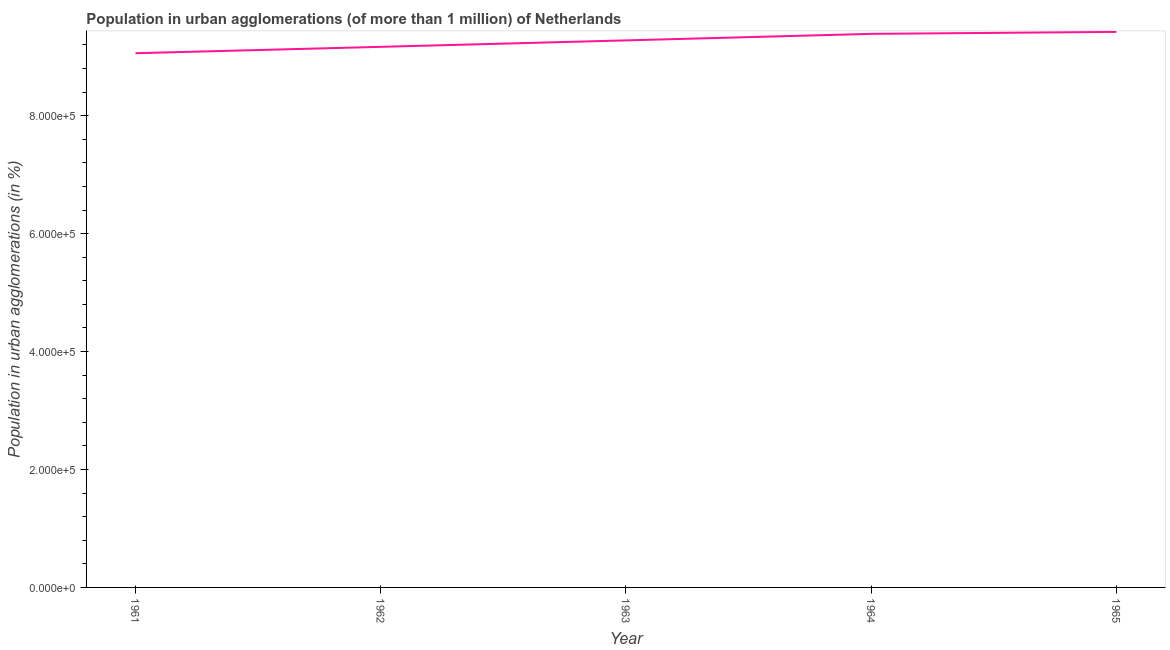What is the population in urban agglomerations in 1965?
Your answer should be very brief. 9.42e+05. Across all years, what is the maximum population in urban agglomerations?
Offer a terse response. 9.42e+05. Across all years, what is the minimum population in urban agglomerations?
Keep it short and to the point. 9.06e+05. In which year was the population in urban agglomerations maximum?
Make the answer very short. 1965. In which year was the population in urban agglomerations minimum?
Give a very brief answer. 1961. What is the sum of the population in urban agglomerations?
Your answer should be compact. 4.63e+06. What is the difference between the population in urban agglomerations in 1961 and 1962?
Make the answer very short. -1.08e+04. What is the average population in urban agglomerations per year?
Provide a succinct answer. 9.26e+05. What is the median population in urban agglomerations?
Keep it short and to the point. 9.28e+05. In how many years, is the population in urban agglomerations greater than 80000 %?
Ensure brevity in your answer.  5. Do a majority of the years between 1964 and 1962 (inclusive) have population in urban agglomerations greater than 640000 %?
Keep it short and to the point. No. What is the ratio of the population in urban agglomerations in 1962 to that in 1965?
Your answer should be very brief. 0.97. Is the population in urban agglomerations in 1961 less than that in 1964?
Ensure brevity in your answer.  Yes. Is the difference between the population in urban agglomerations in 1962 and 1964 greater than the difference between any two years?
Keep it short and to the point. No. What is the difference between the highest and the second highest population in urban agglomerations?
Make the answer very short. 3331. Is the sum of the population in urban agglomerations in 1961 and 1962 greater than the maximum population in urban agglomerations across all years?
Offer a terse response. Yes. What is the difference between the highest and the lowest population in urban agglomerations?
Provide a succinct answer. 3.62e+04. How many lines are there?
Make the answer very short. 1. How many years are there in the graph?
Ensure brevity in your answer.  5. What is the difference between two consecutive major ticks on the Y-axis?
Give a very brief answer. 2.00e+05. Are the values on the major ticks of Y-axis written in scientific E-notation?
Offer a terse response. Yes. Does the graph contain any zero values?
Provide a short and direct response. No. Does the graph contain grids?
Offer a very short reply. No. What is the title of the graph?
Offer a very short reply. Population in urban agglomerations (of more than 1 million) of Netherlands. What is the label or title of the Y-axis?
Give a very brief answer. Population in urban agglomerations (in %). What is the Population in urban agglomerations (in %) in 1961?
Provide a succinct answer. 9.06e+05. What is the Population in urban agglomerations (in %) in 1962?
Your answer should be very brief. 9.17e+05. What is the Population in urban agglomerations (in %) of 1963?
Offer a terse response. 9.28e+05. What is the Population in urban agglomerations (in %) of 1964?
Keep it short and to the point. 9.39e+05. What is the Population in urban agglomerations (in %) of 1965?
Your answer should be compact. 9.42e+05. What is the difference between the Population in urban agglomerations (in %) in 1961 and 1962?
Your response must be concise. -1.08e+04. What is the difference between the Population in urban agglomerations (in %) in 1961 and 1963?
Keep it short and to the point. -2.18e+04. What is the difference between the Population in urban agglomerations (in %) in 1961 and 1964?
Make the answer very short. -3.28e+04. What is the difference between the Population in urban agglomerations (in %) in 1961 and 1965?
Your response must be concise. -3.62e+04. What is the difference between the Population in urban agglomerations (in %) in 1962 and 1963?
Offer a terse response. -1.09e+04. What is the difference between the Population in urban agglomerations (in %) in 1962 and 1964?
Keep it short and to the point. -2.20e+04. What is the difference between the Population in urban agglomerations (in %) in 1962 and 1965?
Ensure brevity in your answer.  -2.54e+04. What is the difference between the Population in urban agglomerations (in %) in 1963 and 1964?
Provide a succinct answer. -1.11e+04. What is the difference between the Population in urban agglomerations (in %) in 1963 and 1965?
Keep it short and to the point. -1.44e+04. What is the difference between the Population in urban agglomerations (in %) in 1964 and 1965?
Offer a terse response. -3331. What is the ratio of the Population in urban agglomerations (in %) in 1961 to that in 1963?
Ensure brevity in your answer.  0.98. What is the ratio of the Population in urban agglomerations (in %) in 1961 to that in 1964?
Make the answer very short. 0.96. What is the ratio of the Population in urban agglomerations (in %) in 1961 to that in 1965?
Keep it short and to the point. 0.96. What is the ratio of the Population in urban agglomerations (in %) in 1962 to that in 1963?
Your response must be concise. 0.99. What is the ratio of the Population in urban agglomerations (in %) in 1963 to that in 1965?
Keep it short and to the point. 0.98. 